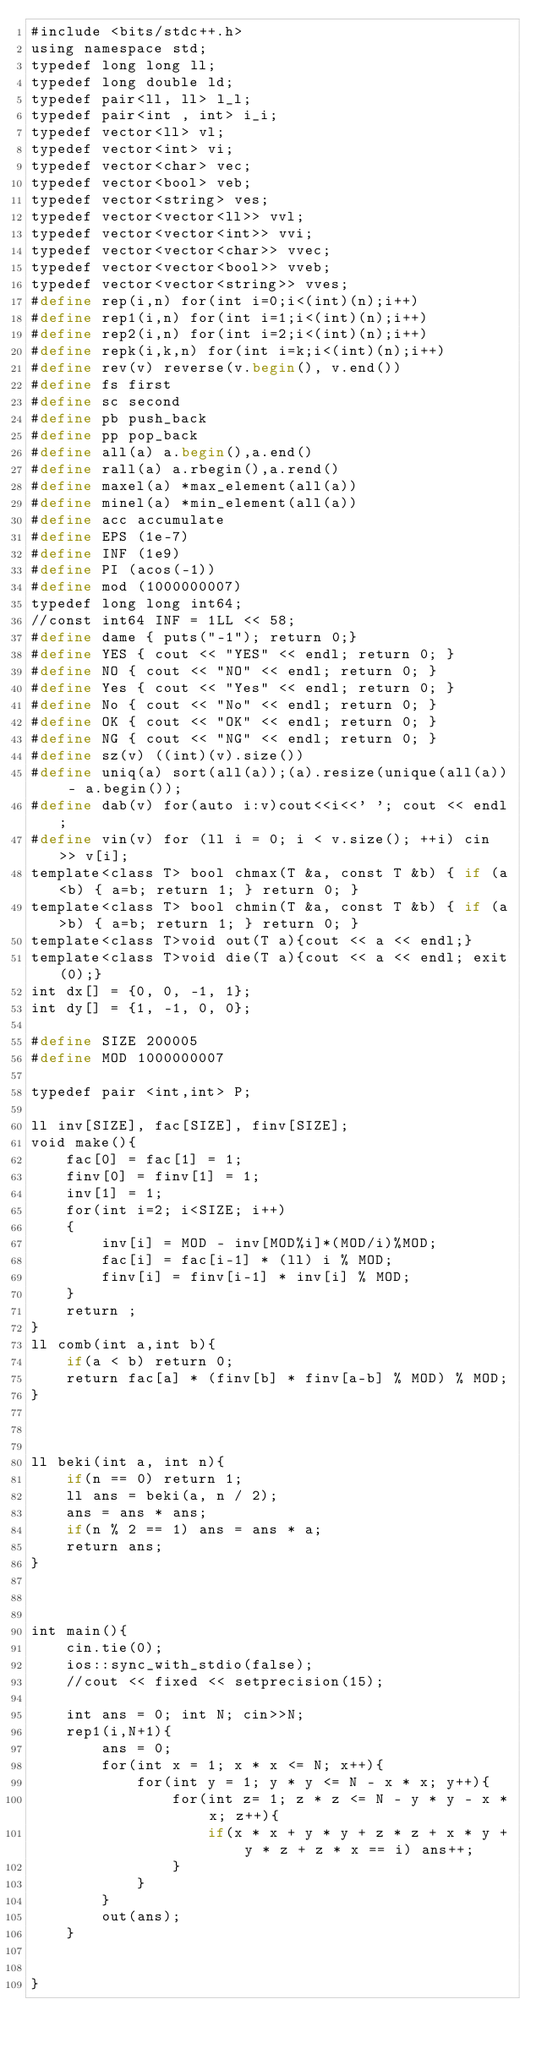Convert code to text. <code><loc_0><loc_0><loc_500><loc_500><_Scheme_>#include <bits/stdc++.h>
using namespace std;
typedef long long ll;
typedef long double ld;
typedef pair<ll, ll> l_l;
typedef pair<int , int> i_i;
typedef vector<ll> vl;
typedef vector<int> vi;
typedef vector<char> vec;
typedef vector<bool> veb;
typedef vector<string> ves;
typedef vector<vector<ll>> vvl;
typedef vector<vector<int>> vvi;
typedef vector<vector<char>> vvec;
typedef vector<vector<bool>> vveb;
typedef vector<vector<string>> vves;
#define rep(i,n) for(int i=0;i<(int)(n);i++)
#define rep1(i,n) for(int i=1;i<(int)(n);i++)
#define rep2(i,n) for(int i=2;i<(int)(n);i++)
#define repk(i,k,n) for(int i=k;i<(int)(n);i++)
#define rev(v) reverse(v.begin(), v.end())
#define fs first
#define sc second
#define pb push_back
#define pp pop_back
#define all(a) a.begin(),a.end()
#define rall(a) a.rbegin(),a.rend()
#define maxel(a) *max_element(all(a))
#define minel(a) *min_element(all(a))
#define acc accumulate
#define EPS (1e-7)
#define INF (1e9)
#define PI (acos(-1))
#define mod (1000000007)
typedef long long int64;
//const int64 INF = 1LL << 58;
#define dame { puts("-1"); return 0;}
#define YES { cout << "YES" << endl; return 0; }
#define NO { cout << "NO" << endl; return 0; }
#define Yes { cout << "Yes" << endl; return 0; }
#define No { cout << "No" << endl; return 0; }
#define OK { cout << "OK" << endl; return 0; }
#define NG { cout << "NG" << endl; return 0; }
#define sz(v) ((int)(v).size())
#define uniq(a) sort(all(a));(a).resize(unique(all(a)) - a.begin());
#define dab(v) for(auto i:v)cout<<i<<' '; cout << endl;
#define vin(v) for (ll i = 0; i < v.size(); ++i) cin >> v[i];
template<class T> bool chmax(T &a, const T &b) { if (a<b) { a=b; return 1; } return 0; }
template<class T> bool chmin(T &a, const T &b) { if (a>b) { a=b; return 1; } return 0; }
template<class T>void out(T a){cout << a << endl;}
template<class T>void die(T a){cout << a << endl; exit(0);}
int dx[] = {0, 0, -1, 1};
int dy[] = {1, -1, 0, 0};

#define SIZE 200005
#define MOD 1000000007
 
typedef pair <int,int> P;
 
ll inv[SIZE], fac[SIZE], finv[SIZE];
void make(){
	fac[0] = fac[1] = 1;
	finv[0] = finv[1] = 1;
	inv[1] = 1;
	for(int i=2; i<SIZE; i++)
	{
		inv[i] = MOD - inv[MOD%i]*(MOD/i)%MOD;
		fac[i] = fac[i-1] * (ll) i % MOD;
		finv[i] = finv[i-1] * inv[i] % MOD;
	}
    return ;
}
ll comb(int a,int b){
	if(a < b) return 0;
	return fac[a] * (finv[b] * finv[a-b] % MOD) % MOD;
}



ll beki(int a, int n){
    if(n == 0) return 1;
    ll ans = beki(a, n / 2);
    ans = ans * ans;
    if(n % 2 == 1) ans = ans * a;
    return ans;
}



int main(){
	cin.tie(0);
	ios::sync_with_stdio(false);
    //cout << fixed << setprecision(15);
    
    int ans = 0; int N; cin>>N;
	rep1(i,N+1){
		ans = 0;
		for(int x = 1; x * x <= N; x++){
			for(int y = 1; y * y <= N - x * x; y++){
				for(int z= 1; z * z <= N - y * y - x * x; z++){
					if(x * x + y * y + z * z + x * y + y * z + z * x == i) ans++;
				}
			}
		}
		out(ans);
	}

	
}</code> 